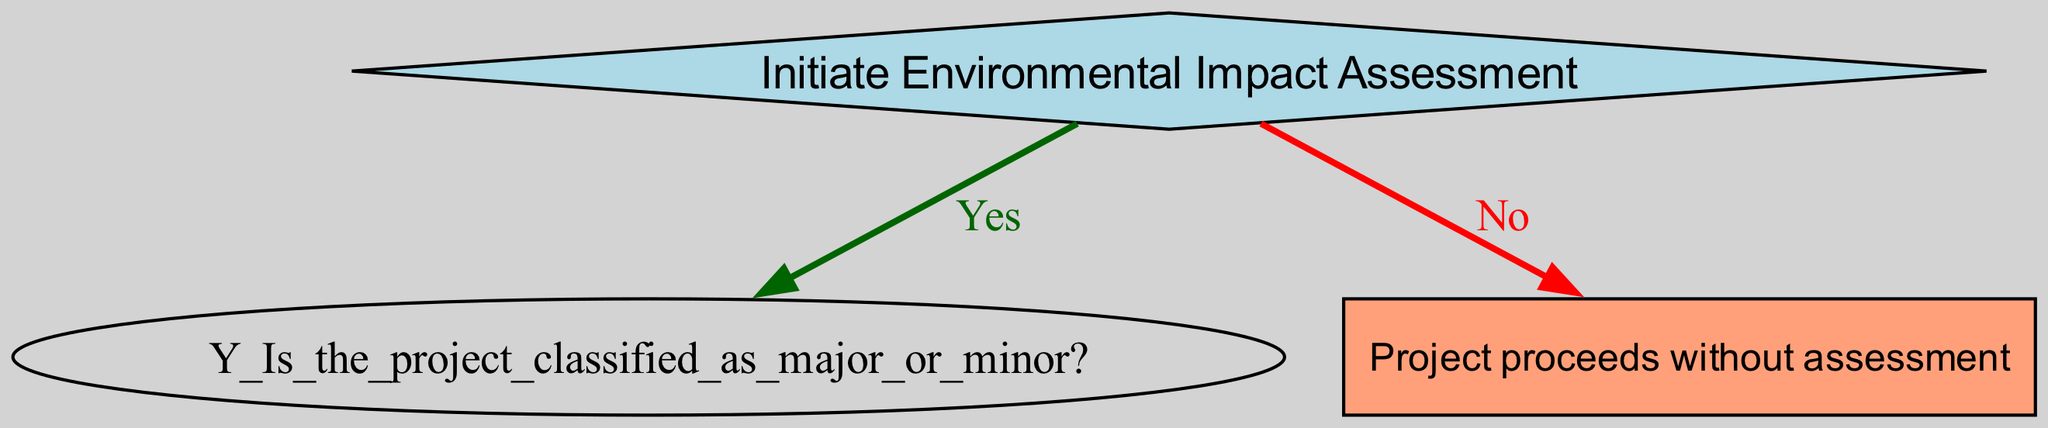What's the first decision in the diagram? The diagram starts with the "Initiate Environmental Impact Assessment" as the first decision depicted at the root of the tree.
Answer: Initiate Environmental Impact Assessment How many outputs are generated if the project is classified as minor? The "Minor" path leads to two outputs: "Assurance Document" and "Compliance Checklist". Hence, there are two outputs generated in this scenario.
Answer: 2 What happens if the community feedback is collected? If community feedback is collected, the next step is to create a "Report Drafted" as one of the outputs along with the "Community Feedback". This indicates involvement of the community in the assessment process.
Answer: Report Drafted Which decision follows after conducting scoping for a major project? After conducting scoping for a major project, the next decision is "Stakeholder Involvement Required?". This determines whether consultation with the community is necessary.
Answer: Stakeholder Involvement Required? What is the outcome if the project does not initiate an Environmental Impact Assessment? If the project does not initiate an Environmental Impact Assessment, the clear outcome illustrated in the diagram is that "Project proceeds without assessment".
Answer: Project proceeds without assessment How many total nodes are present in the tree? This decision tree consists of 8 nodes, including the root, decisions for major and minor classifications, their respective next decisions, outputs, and the outcome for no assessment.
Answer: 8 What type of assessment process is used for minor projects? The diagram indicates that for minor projects, a "Simplified Assessment Process" is utilized to streamline evaluation.
Answer: Simplified Assessment Process What do you get if stakeholder involvement is not required after scoping? If stakeholder involvement is not required after scoping, the next step is to "Proceed to Impact Analysis," leading to the output of an "Impact Report".
Answer: Proceed to Impact Analysis 